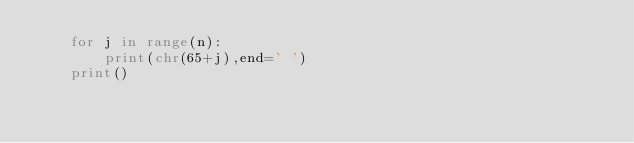Convert code to text. <code><loc_0><loc_0><loc_500><loc_500><_Python_>    for j in range(n):
        print(chr(65+j),end=' ')
    print()</code> 